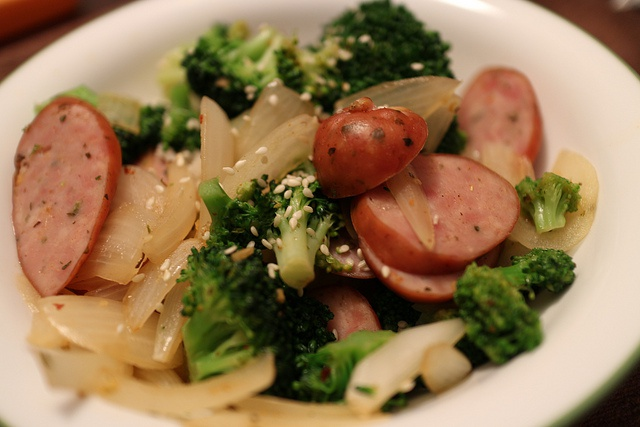Describe the objects in this image and their specific colors. I can see bowl in red, lightgray, and tan tones, broccoli in red, black, olive, tan, and darkgreen tones, broccoli in red, black, olive, tan, and darkgreen tones, broccoli in red, black, darkgreen, and olive tones, and broccoli in red, black, tan, and olive tones in this image. 